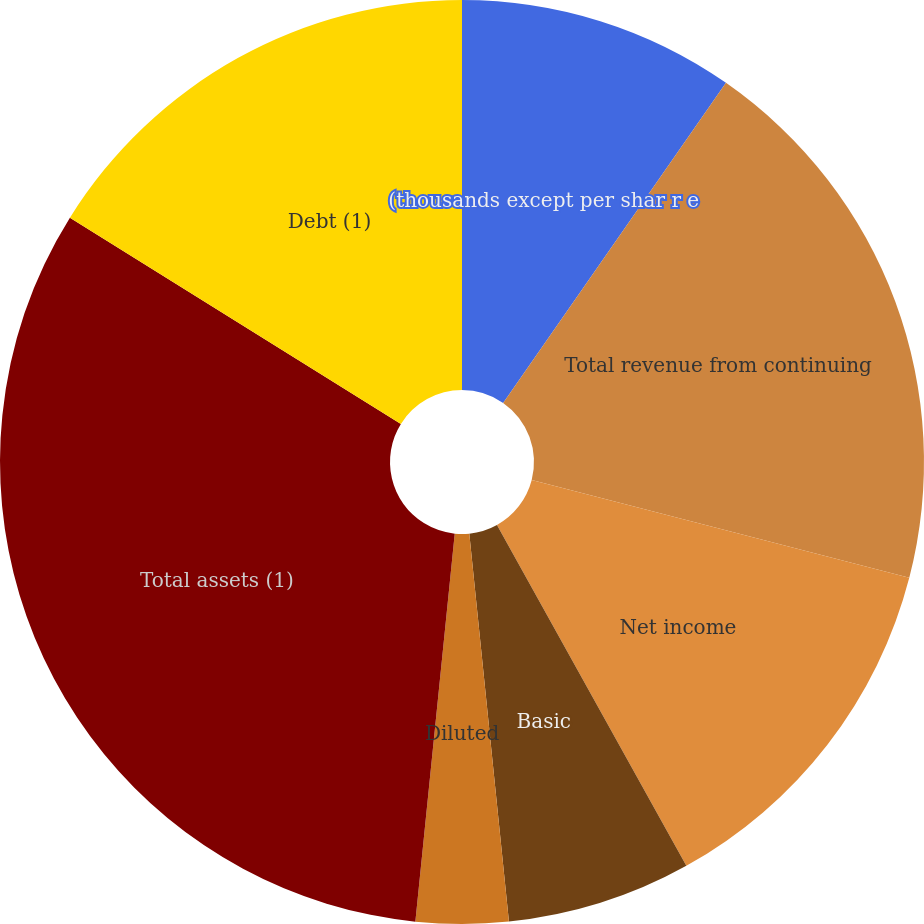<chart> <loc_0><loc_0><loc_500><loc_500><pie_chart><fcel>(thousands except per shar r e<fcel>Total revenue from continuing<fcel>Net income<fcel>Basic<fcel>Diluted<fcel>Cash dividends declared per<fcel>Total assets (1)<fcel>Debt (1)<nl><fcel>9.68%<fcel>19.35%<fcel>12.9%<fcel>6.45%<fcel>3.23%<fcel>0.0%<fcel>32.26%<fcel>16.13%<nl></chart> 